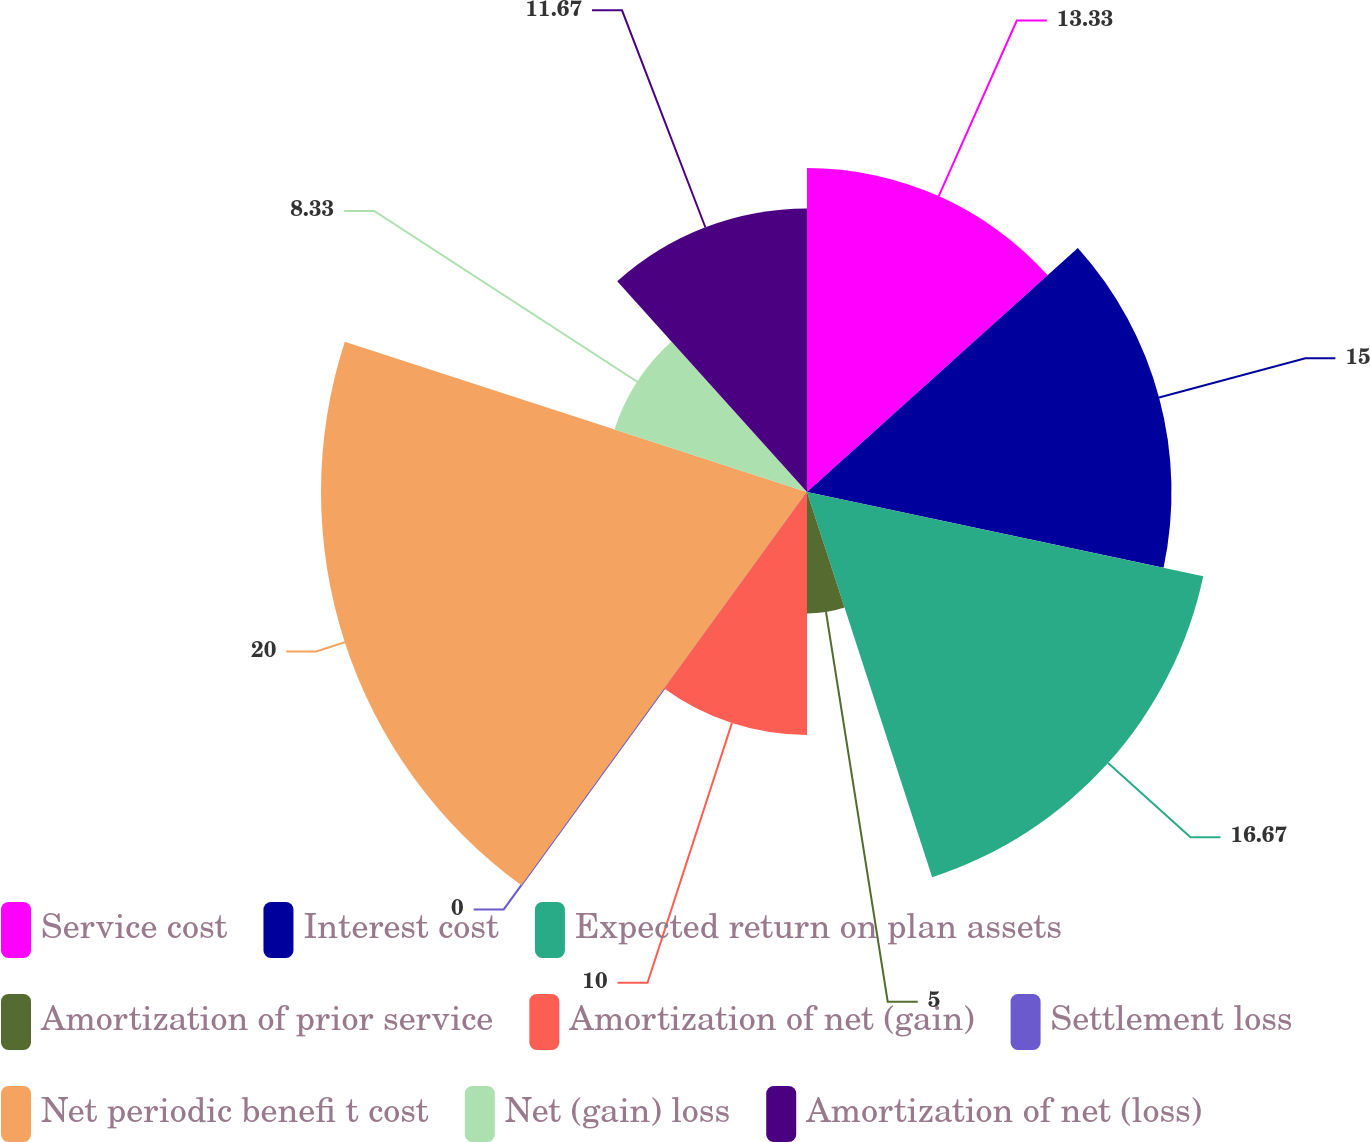Convert chart. <chart><loc_0><loc_0><loc_500><loc_500><pie_chart><fcel>Service cost<fcel>Interest cost<fcel>Expected return on plan assets<fcel>Amortization of prior service<fcel>Amortization of net (gain)<fcel>Settlement loss<fcel>Net periodic benefi t cost<fcel>Net (gain) loss<fcel>Amortization of net (loss)<nl><fcel>13.33%<fcel>15.0%<fcel>16.67%<fcel>5.0%<fcel>10.0%<fcel>0.0%<fcel>20.0%<fcel>8.33%<fcel>11.67%<nl></chart> 